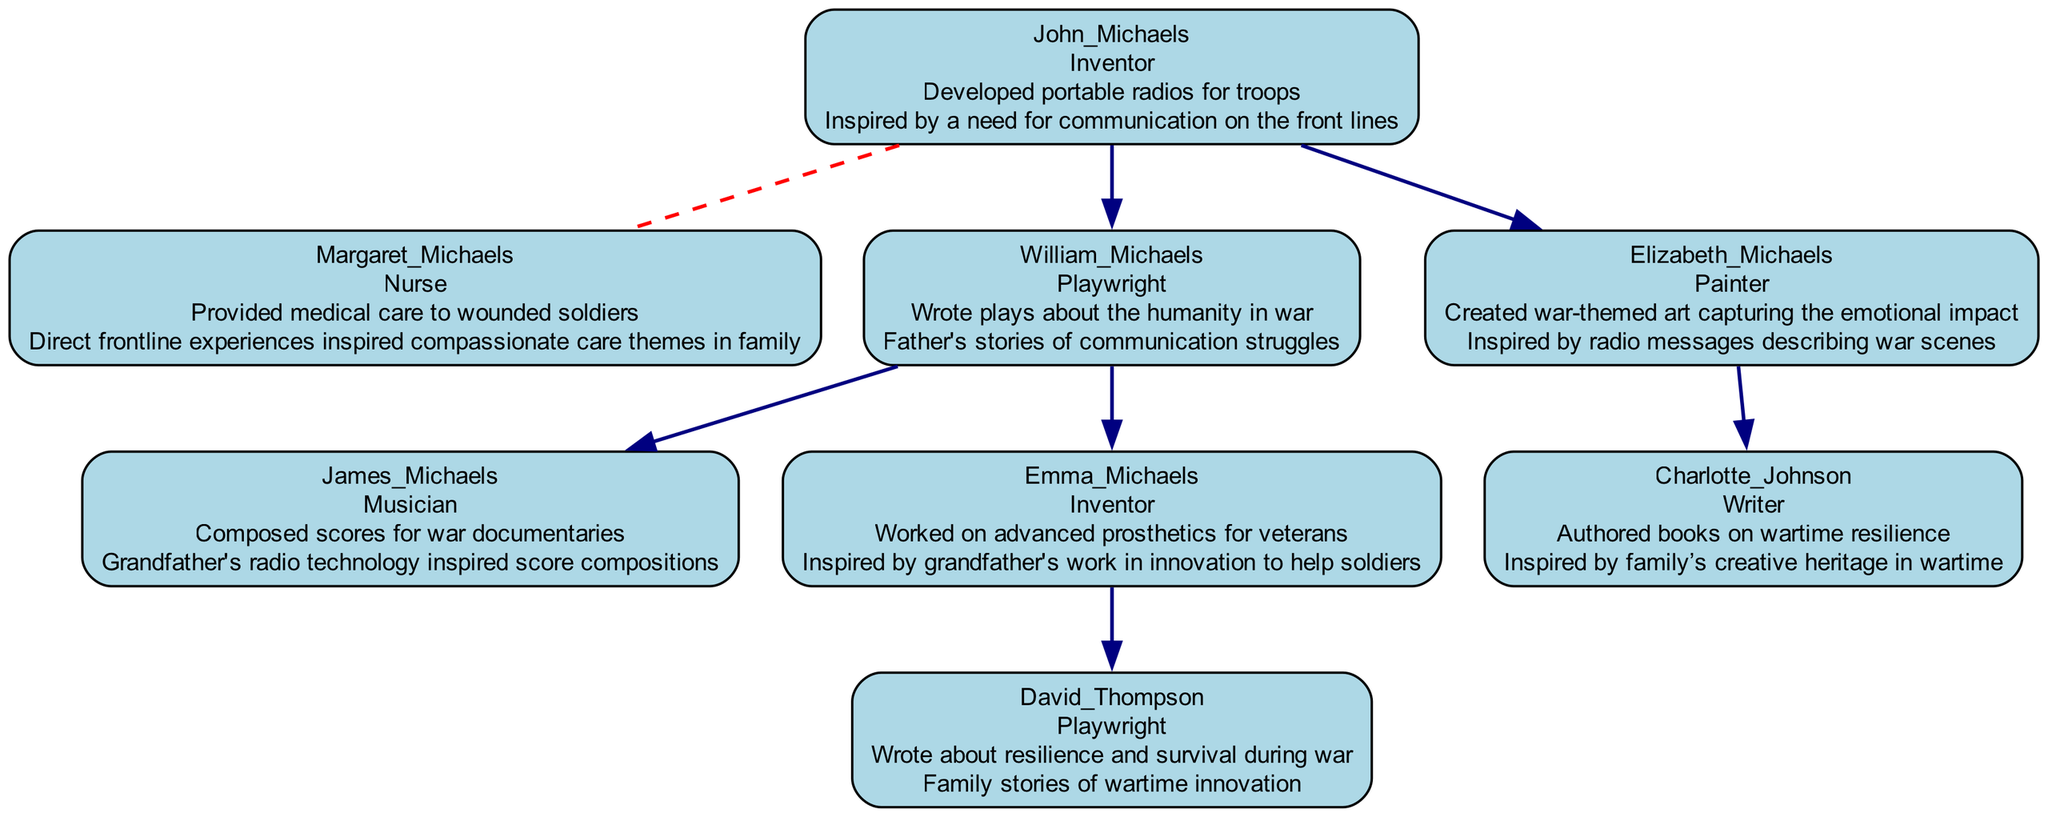What is the contribution of John Michaels? John Michaels is noted for developing portable radios for troops. The label within the diagram provides specific details about his role and his contribution to wartime innovation.
Answer: Developed portable radios for troops Who is the spouse of William Michaels? William Michaels is married to Alice Michaels. This information is depicted in the diagram through the dashed line linking them, indicating their marital relationship.
Answer: Alice Michaels How many children does Elizabeth Michaels have? Elizabeth Michaels has one child, Charlotte Johnson. The diagram shows that the "children" section of Elizabeth only lists Charlotte, indicating she has one descendant.
Answer: 1 What is the role of Emma Michaels? Emma Michaels is identified as an inventor in the diagram. The information is directly labeled under her name, making it clear what her professional identity is within the family tree.
Answer: Inventor What inspired David Thompson's works? David Thompson's works are inspired by family stories of wartime innovation. The diagram connects his inspiration to his family's creative heritage through explicit mention under his profile.
Answer: Family stories of wartime innovation How many generations are represented in the family tree? The family tree consists of three generations: John and Margaret Michaels (the parents), their children William and Elizabeth, and the grandchildren (James, Emma, David, and Charlotte). By counting the layers from the top to the youngest descendants, we confirm these three generations.
Answer: 3 What is the contribution of Margaret Michaels? Margaret Michaels provided medical care to wounded soldiers. Her role and contribution are clearly listed under her name in the diagram, which highlights her significant role during wartime.
Answer: Provided medical care to wounded soldiers What wartime experience influenced James Michaels' music? James Michaels' music was inspired by his grandfather's radio technology, which is noted in the diagram as a pivotal influence on his creative work in composing scores.
Answer: Grandfather's radio technology How is the relationship between Charlotte Johnson and Elizabeth Michaels? Charlotte Johnson is the daughter of Elizabeth Michaels, as indicated in the child section of Elizabeth's profile in the diagram. This direct lineage showcases their mother-daughter relationship.
Answer: Daughter 